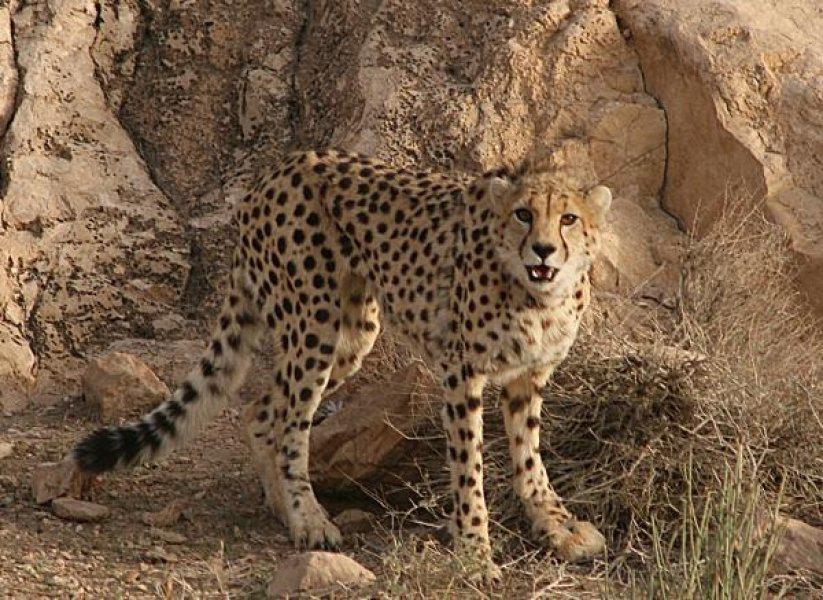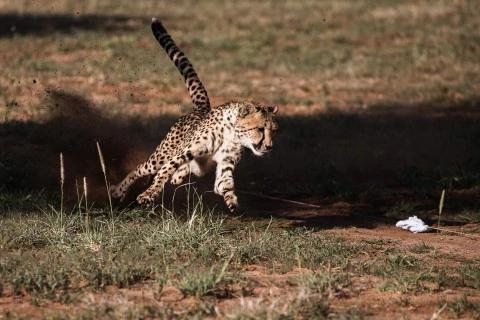The first image is the image on the left, the second image is the image on the right. Assess this claim about the two images: "There are exactly three cheetahs in the left image.". Correct or not? Answer yes or no. No. The first image is the image on the left, the second image is the image on the right. Examine the images to the left and right. Is the description "The left image shows at least one cheetah standing in front of mounded dirt, and the right image contains just one cheetah." accurate? Answer yes or no. Yes. 